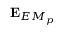Convert formula to latex. <formula><loc_0><loc_0><loc_500><loc_500>E _ { E M _ { p } }</formula> 